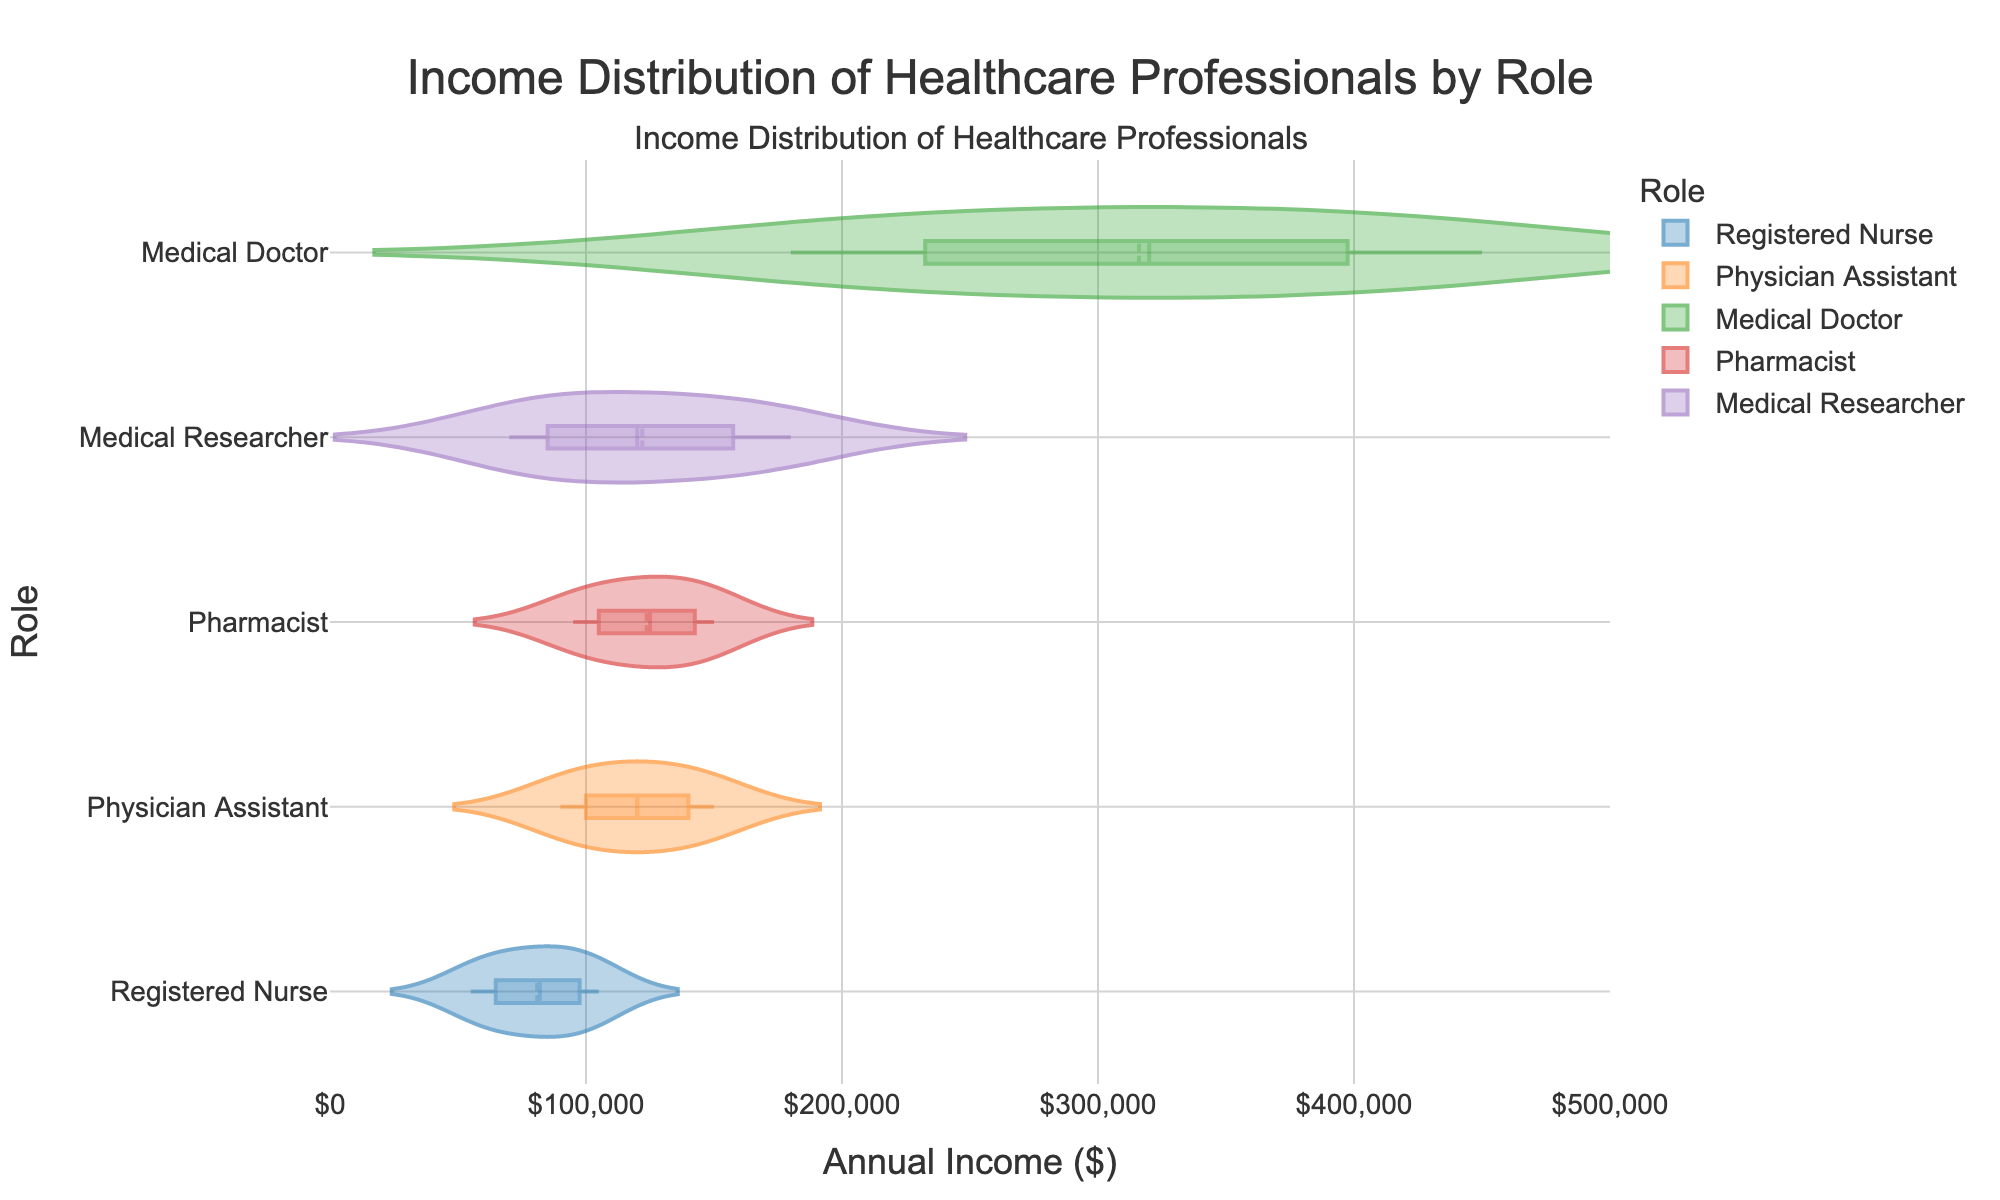What's the title of the plot? The title of the plot is centered at the top of the figure and is clearly displayed. It states: "Income Distribution of Healthcare Professionals by Role".
Answer: Income Distribution of Healthcare Professionals by Role Which role has the highest income range? By looking at the width of the horizontal density plots, we can observe that Medical Doctors have the highest income range, extending from $180,000 to $450,000. This is the widest spread on the x-axis.
Answer: Medical Doctors What is the median income for Registered Nurses? The median income is displayed by the line in the middle of the box plot within the density plot for Registered Nurses. From the figure, this line is approximately at $82,000.
Answer: $82,000 How do the mean incomes of Medical Researchers and Pharmacists compare? The mean income is shown by the meanline within the density plots. Comparing the positions of these meanlines, we see that Medical Researchers have a mean income around $120,000 while Pharmacists have a mean income slightly above $115,000.
Answer: Medical Researchers have a higher mean income Which role appears to have the least variability in income distribution? By comparing the spreads of the density plots visually, the plot for Medical Researchers is the most concentrated, suggesting the least variability.
Answer: Medical Researchers What is the range of annual incomes for Physician Assistants with 3 to 18 years of experience? The horizontal span of the density plot for Physician Assistants stretches from $90,000 to $150,000.
Answer: $90,000 to $150,000 How does the income distribution of Registered Nurses compare to Pharmacists? Comparing the density plots, Registered Nurses have a wider income distribution ($55,000 to $105,000) compared to Pharmacists ($95,000 to $150,000). The lower income boundary for Registered Nurses is below that of Pharmacists.
Answer: Registered Nurses have a wider distribution with a lower boundary What can you say about the income trend of healthcare professionals with increasing experience? Observing the income distributions, the mean and median incomes tend to increase with experience across all roles represented. Higher experience levels generally correspond with higher annual incomes.
Answer: Incomes increase with experience Which role has the highest median income? The median income is shown by the line within the box plot of the density plot. Medical Doctors have the highest median income, which appears roughly at $320,000.
Answer: Medical Doctors 